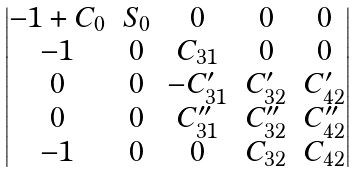<formula> <loc_0><loc_0><loc_500><loc_500>\begin{vmatrix} - 1 + C _ { 0 } & S _ { 0 } & 0 & 0 & 0 \\ - 1 & 0 & C _ { 3 1 } & 0 & 0 \\ 0 & 0 & - C ^ { \prime } _ { 3 1 } & C ^ { \prime } _ { 3 2 } & C ^ { \prime } _ { 4 2 } \\ 0 & 0 & C ^ { \prime \prime } _ { 3 1 } & C ^ { \prime \prime } _ { 3 2 } & C ^ { \prime \prime } _ { 4 2 } \\ - 1 & 0 & 0 & C _ { 3 2 } & C _ { 4 2 } \end{vmatrix}</formula> 